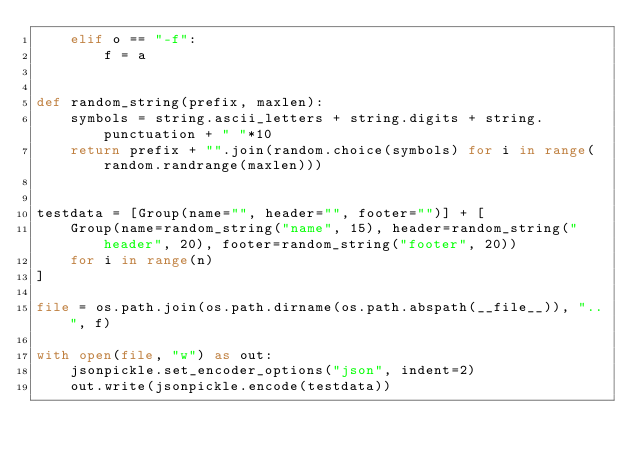<code> <loc_0><loc_0><loc_500><loc_500><_Python_>    elif o == "-f":
        f = a


def random_string(prefix, maxlen):
    symbols = string.ascii_letters + string.digits + string.punctuation + " "*10
    return prefix + "".join(random.choice(symbols) for i in range(random.randrange(maxlen)))


testdata = [Group(name="", header="", footer="")] + [
    Group(name=random_string("name", 15), header=random_string("header", 20), footer=random_string("footer", 20))
    for i in range(n)
]

file = os.path.join(os.path.dirname(os.path.abspath(__file__)), "..", f)

with open(file, "w") as out:
    jsonpickle.set_encoder_options("json", indent=2)
    out.write(jsonpickle.encode(testdata))</code> 